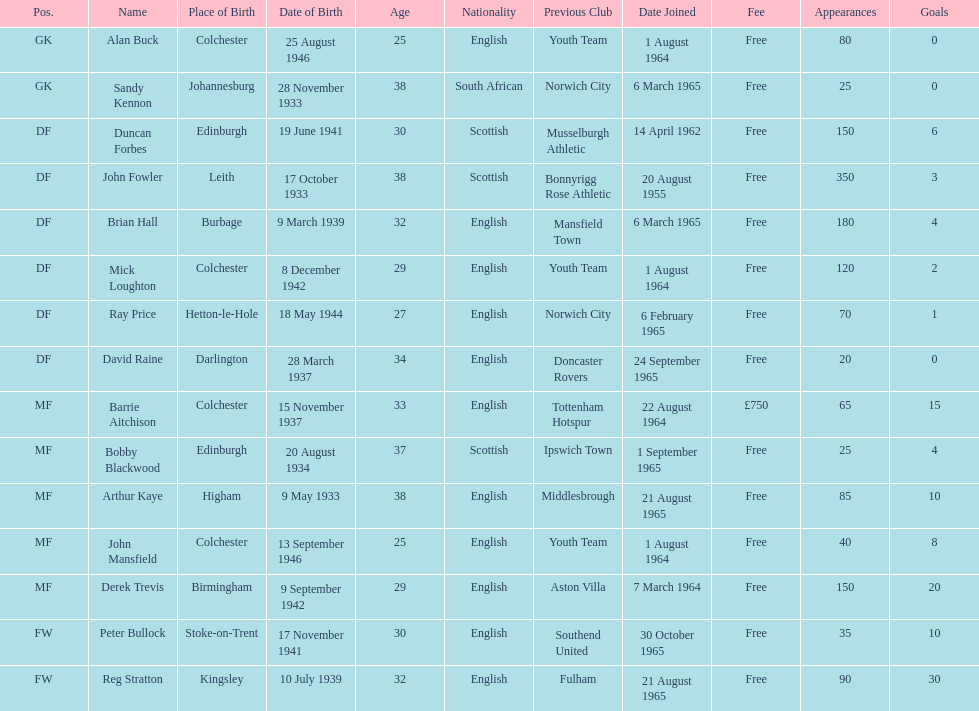What is the date of the lst player that joined? 20 August 1955. Help me parse the entirety of this table. {'header': ['Pos.', 'Name', 'Place of Birth', 'Date of Birth', 'Age', 'Nationality', 'Previous Club', 'Date Joined', 'Fee', 'Appearances', 'Goals'], 'rows': [['GK', 'Alan Buck', 'Colchester', '25 August 1946', '25', 'English', 'Youth Team', '1 August 1964', 'Free', '80', '0'], ['GK', 'Sandy Kennon', 'Johannesburg', '28 November 1933', '38', 'South African', 'Norwich City', '6 March 1965', 'Free', '25', '0'], ['DF', 'Duncan Forbes', 'Edinburgh', '19 June 1941', '30', 'Scottish', 'Musselburgh Athletic', '14 April 1962', 'Free', '150', '6'], ['DF', 'John Fowler', 'Leith', '17 October 1933', '38', 'Scottish', 'Bonnyrigg Rose Athletic', '20 August 1955', 'Free', '350', '3'], ['DF', 'Brian Hall', 'Burbage', '9 March 1939', '32', 'English', 'Mansfield Town', '6 March 1965', 'Free', '180', '4'], ['DF', 'Mick Loughton', 'Colchester', '8 December 1942', '29', 'English', 'Youth Team', '1 August 1964', 'Free', '120', '2'], ['DF', 'Ray Price', 'Hetton-le-Hole', '18 May 1944', '27', 'English', 'Norwich City', '6 February 1965', 'Free', '70', '1'], ['DF', 'David Raine', 'Darlington', '28 March 1937', '34', 'English', 'Doncaster Rovers', '24 September 1965', 'Free', '20', '0'], ['MF', 'Barrie Aitchison', 'Colchester', '15 November 1937', '33', 'English', 'Tottenham Hotspur', '22 August 1964', '£750', '65', '15'], ['MF', 'Bobby Blackwood', 'Edinburgh', '20 August 1934', '37', 'Scottish', 'Ipswich Town', '1 September 1965', 'Free', '25', '4'], ['MF', 'Arthur Kaye', 'Higham', '9 May 1933', '38', 'English', 'Middlesbrough', '21 August 1965', 'Free', '85', '10'], ['MF', 'John Mansfield', 'Colchester', '13 September 1946', '25', 'English', 'Youth Team', '1 August 1964', 'Free', '40', '8'], ['MF', 'Derek Trevis', 'Birmingham', '9 September 1942', '29', 'English', 'Aston Villa', '7 March 1964', 'Free', '150', '20'], ['FW', 'Peter Bullock', 'Stoke-on-Trent', '17 November 1941', '30', 'English', 'Southend United', '30 October 1965', 'Free', '35', '10'], ['FW', 'Reg Stratton', 'Kingsley', '10 July 1939', '32', 'English', 'Fulham', '21 August 1965', 'Free', '90', '30']]} 